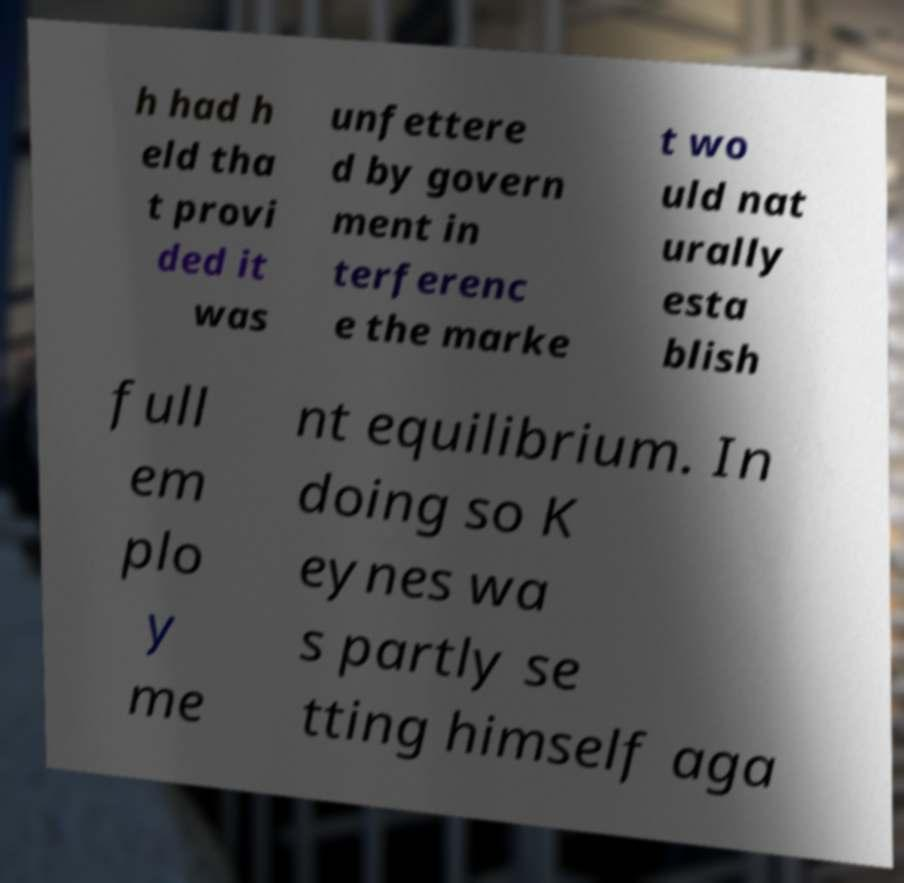Could you assist in decoding the text presented in this image and type it out clearly? h had h eld tha t provi ded it was unfettere d by govern ment in terferenc e the marke t wo uld nat urally esta blish full em plo y me nt equilibrium. In doing so K eynes wa s partly se tting himself aga 